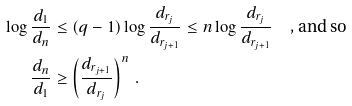<formula> <loc_0><loc_0><loc_500><loc_500>\log \frac { d _ { 1 } } { d _ { n } } & \leq ( q - 1 ) \log \frac { d _ { r _ { j } } } { d _ { r _ { j + 1 } } } \leq n \log \frac { d _ { r _ { j } } } { d _ { r _ { j + 1 } } } \text {\quad, and so} \\ \frac { d _ { n } } { d _ { 1 } } & \geq \left ( \frac { d _ { r _ { j + 1 } } } { d _ { r _ { j } } } \right ) ^ { n } \, .</formula> 